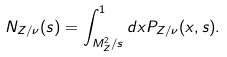<formula> <loc_0><loc_0><loc_500><loc_500>N _ { Z / \nu } ( s ) = \int _ { M _ { Z } ^ { 2 } / s } ^ { 1 } d x P _ { Z / \nu } ( x , s ) .</formula> 